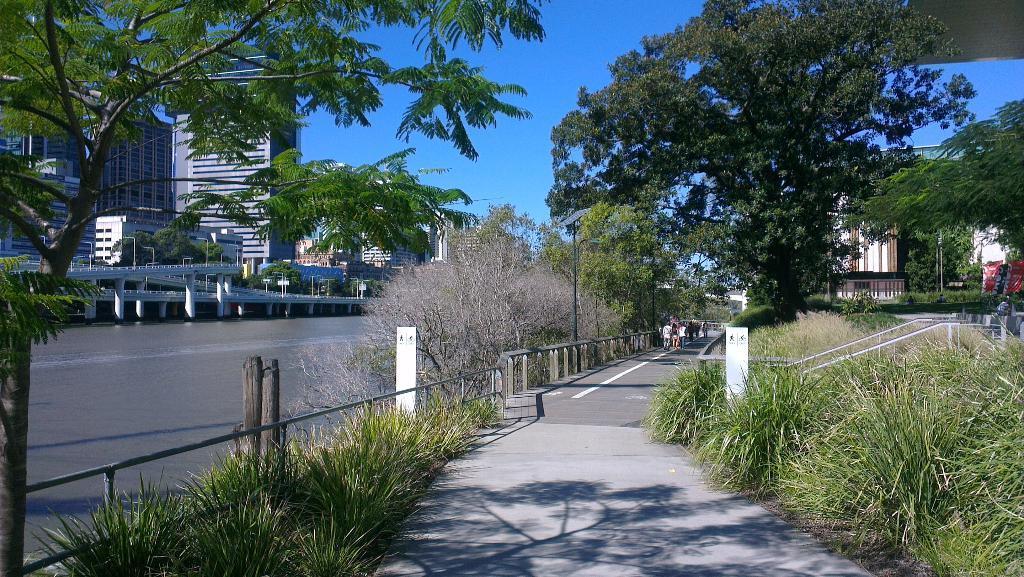How would you summarize this image in a sentence or two? In this image there are group of people standing, a walkway, grass, plants, iron rods, water, bridge, trees, poles, lights, buildings,and there is sky. 